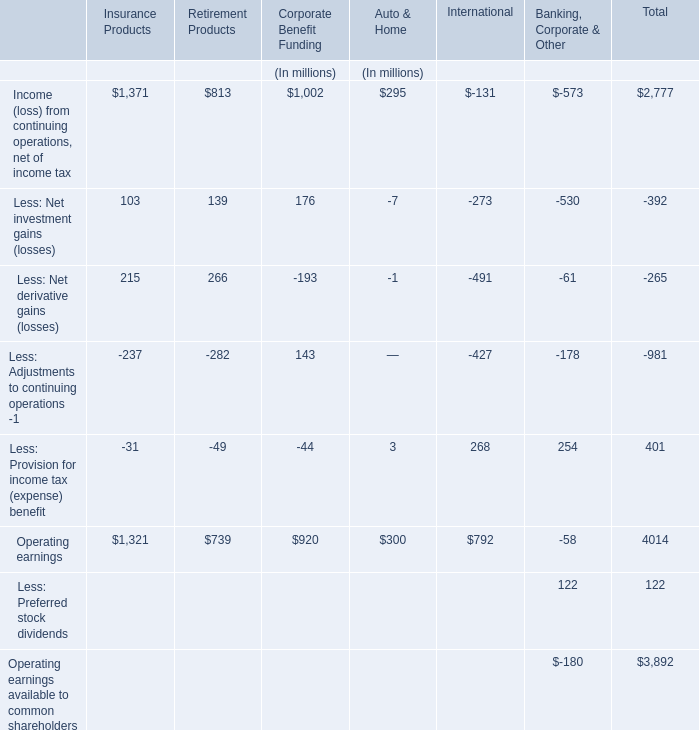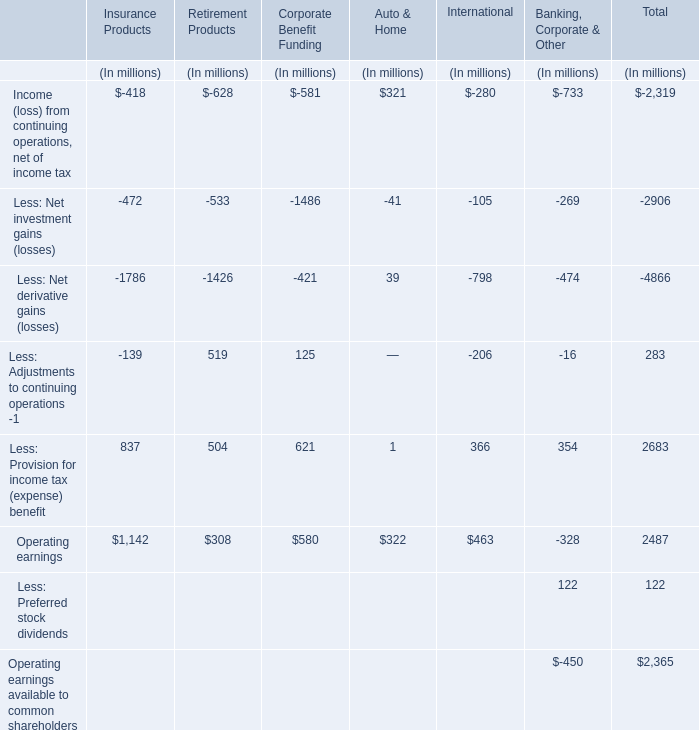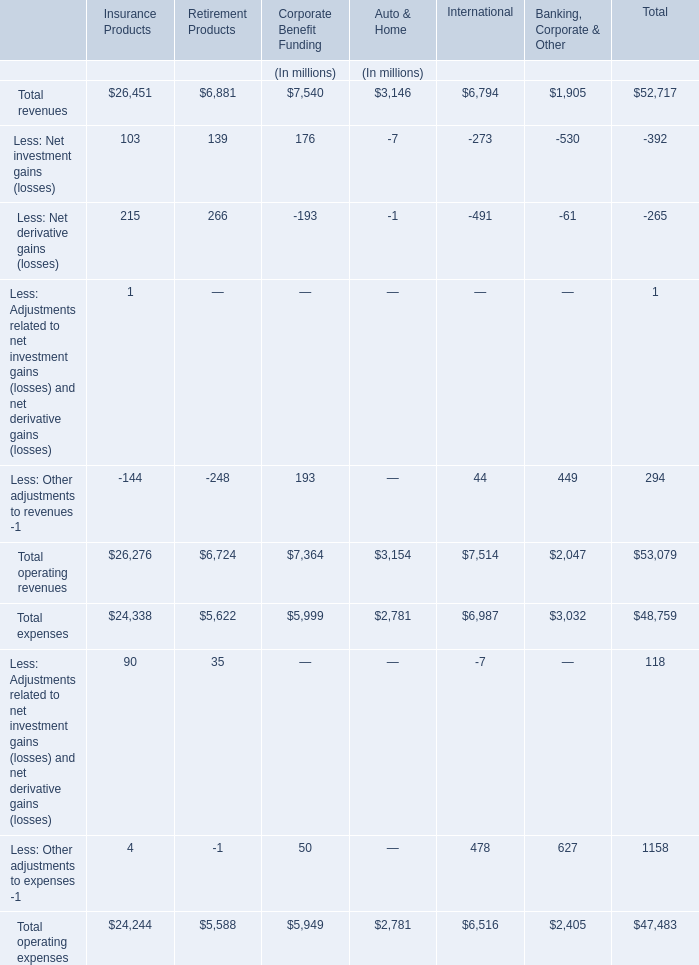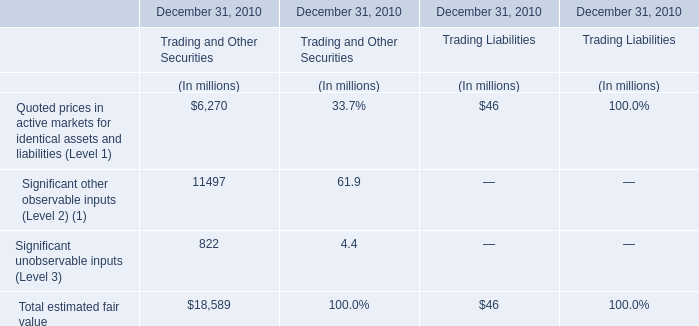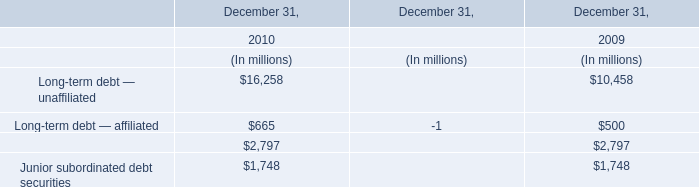What's the 30 % of total Operating earnings? (in million) 
Computations: (2487 * 0.3)
Answer: 746.1. What is the proportion of international to the total in total revenue? (in %) 
Computations: (6794 / 52717)
Answer: 0.12888. 